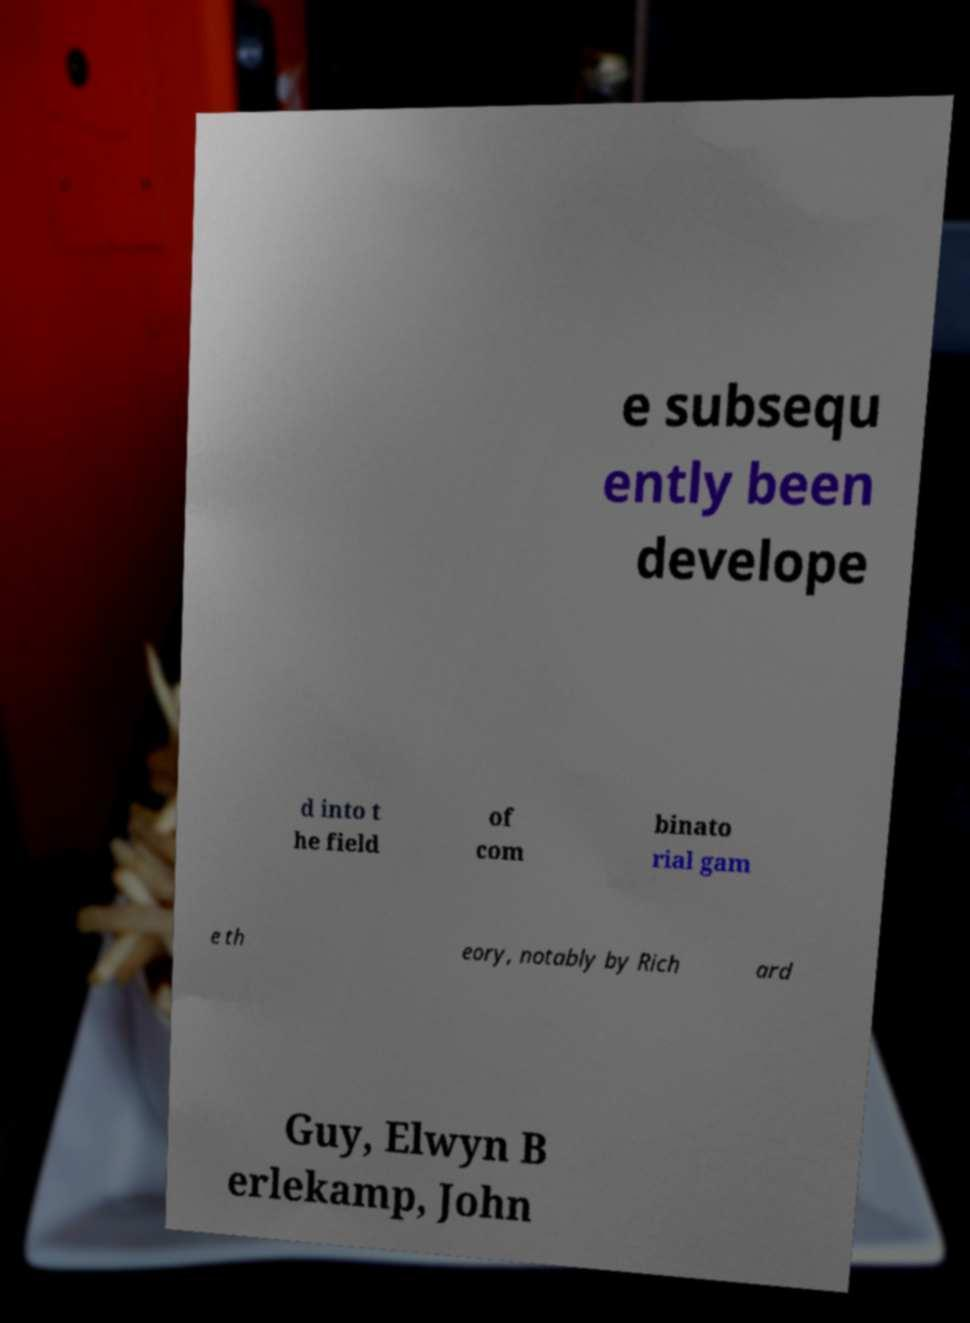Please read and relay the text visible in this image. What does it say? e subsequ ently been develope d into t he field of com binato rial gam e th eory, notably by Rich ard Guy, Elwyn B erlekamp, John 